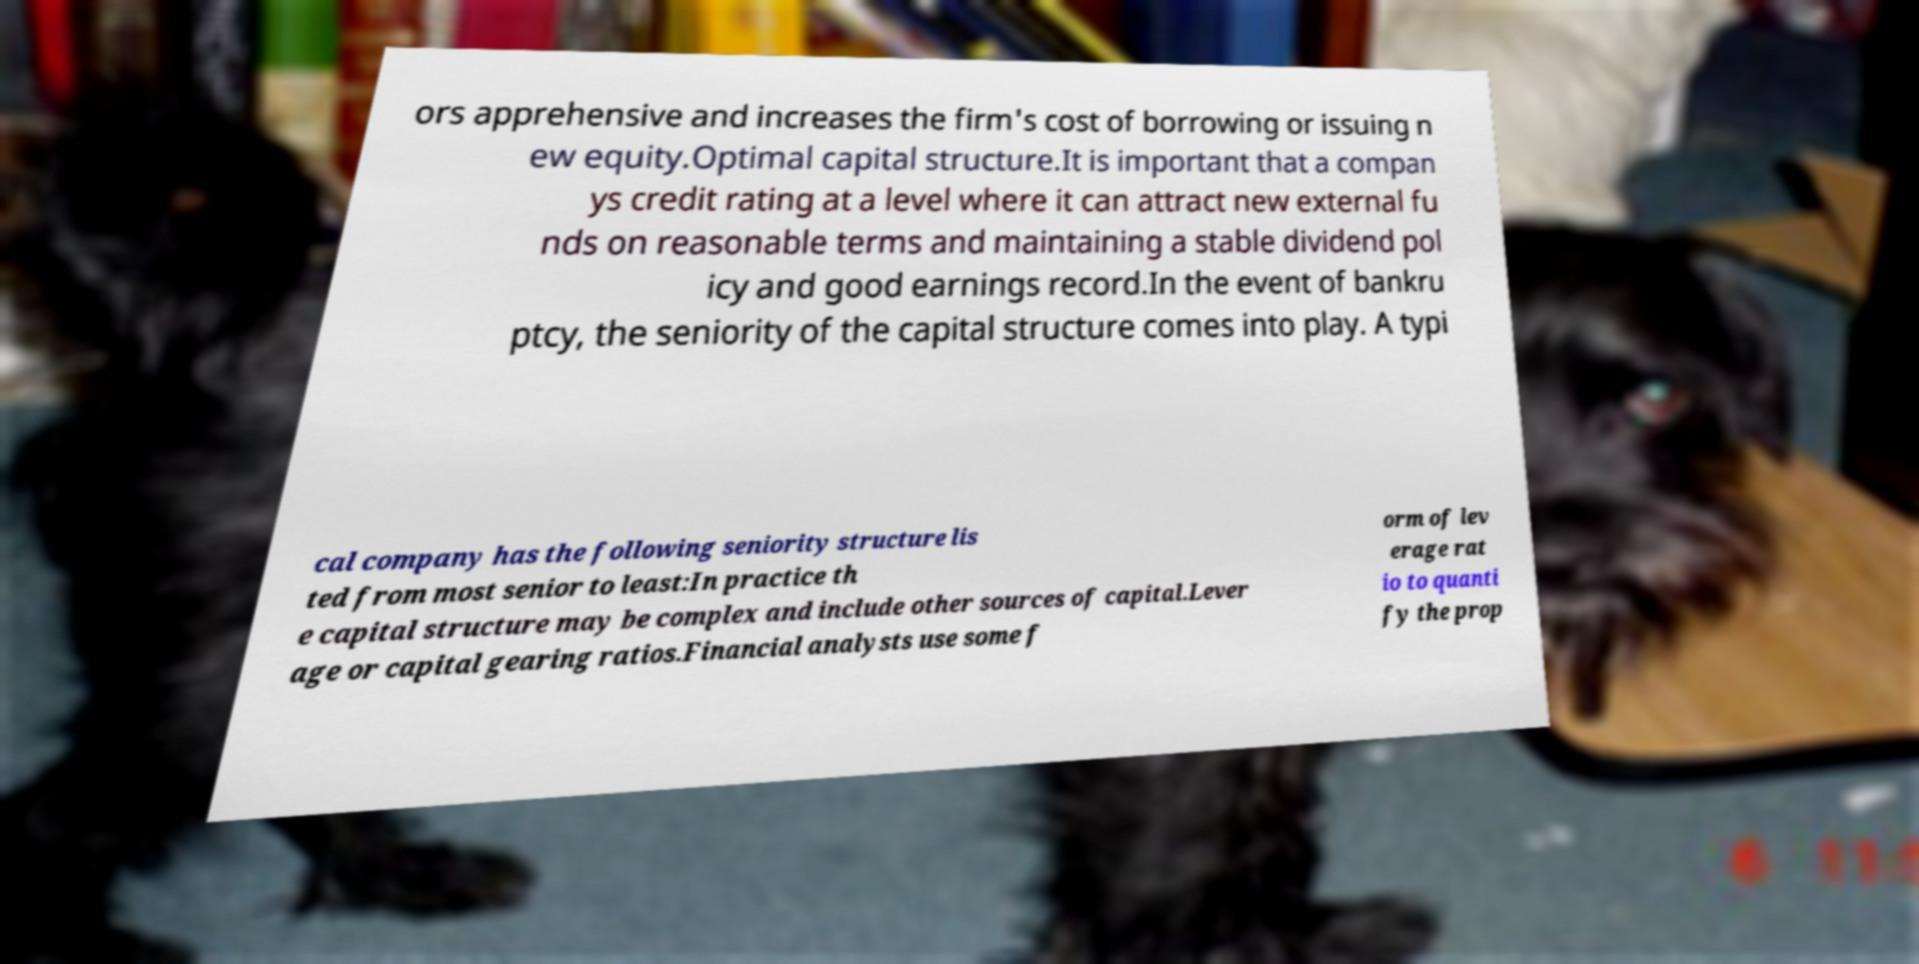For documentation purposes, I need the text within this image transcribed. Could you provide that? ors apprehensive and increases the firm's cost of borrowing or issuing n ew equity.Optimal capital structure.It is important that a compan ys credit rating at a level where it can attract new external fu nds on reasonable terms and maintaining a stable dividend pol icy and good earnings record.In the event of bankru ptcy, the seniority of the capital structure comes into play. A typi cal company has the following seniority structure lis ted from most senior to least:In practice th e capital structure may be complex and include other sources of capital.Lever age or capital gearing ratios.Financial analysts use some f orm of lev erage rat io to quanti fy the prop 